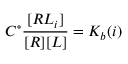Convert formula to latex. <formula><loc_0><loc_0><loc_500><loc_500>C ^ { \circ } \frac { [ R L _ { i } ] } { [ R ] [ L ] } = K _ { b } ( i )</formula> 